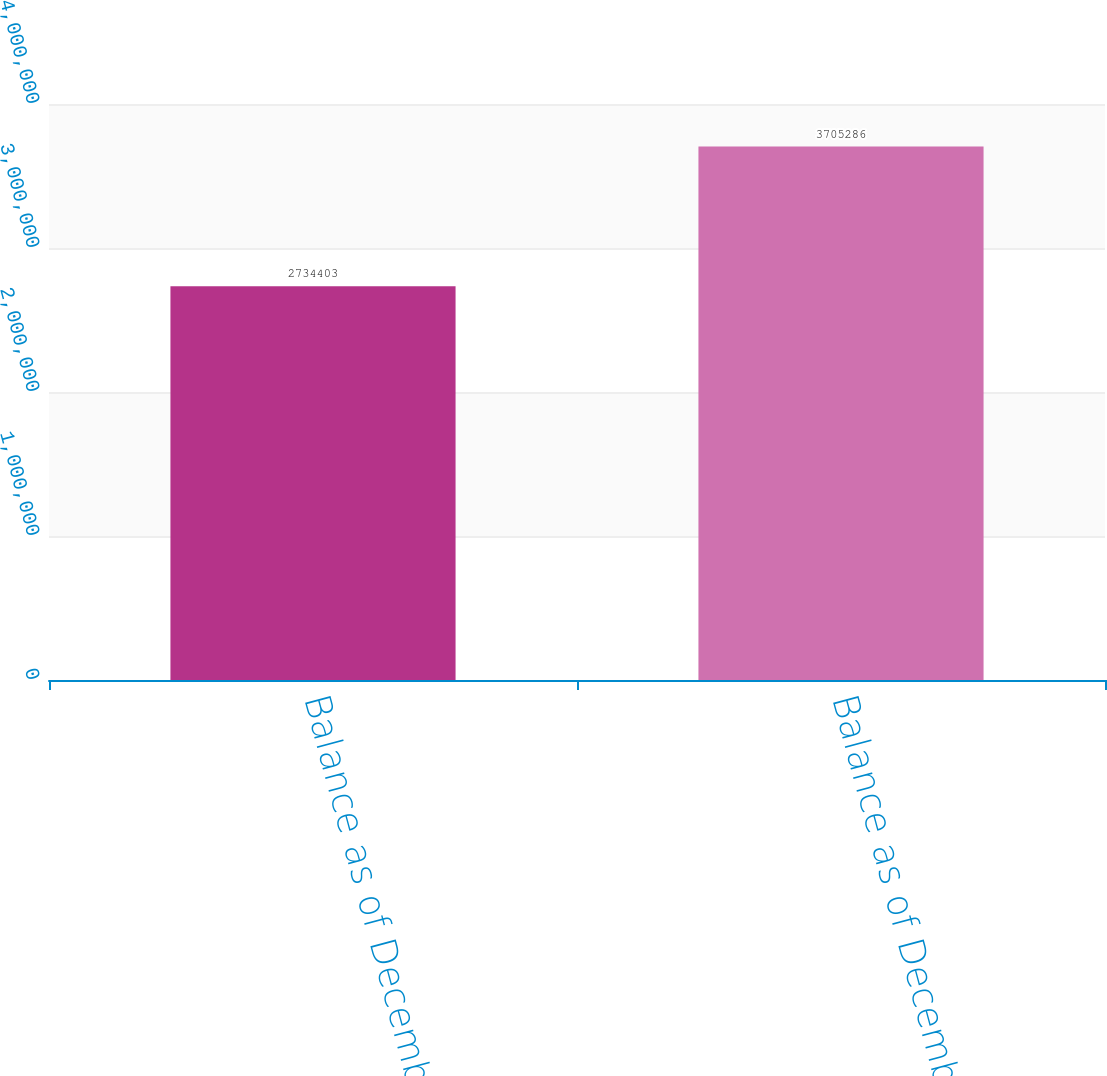<chart> <loc_0><loc_0><loc_500><loc_500><bar_chart><fcel>Balance as of December 31 2003<fcel>Balance as of December 31 2004<nl><fcel>2.7344e+06<fcel>3.70529e+06<nl></chart> 